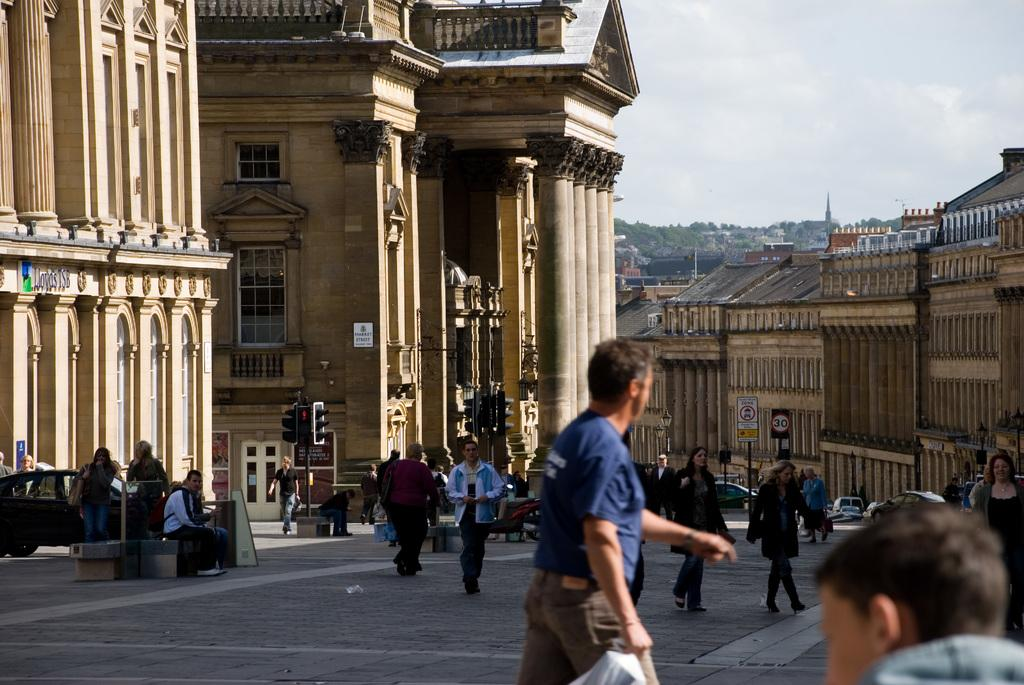What are the people in the image doing? The people in the image are walking. What can be seen in the background of the image? There are buildings with windows and trees visible in the distance. What is on the wall in the image? There is a board on a wall in the image, and it appears to be a sign board. What else can be seen on the road in the image? Vehicles are present on the road in the image. What is the reason for the attraction in the image? There is no attraction present in the image; it features people walking, buildings, trees, a sign board, and vehicles on the road. Can you tell me how fast the people are running in the image? The people in the image are walking, not running, so there is no speed to measure. 